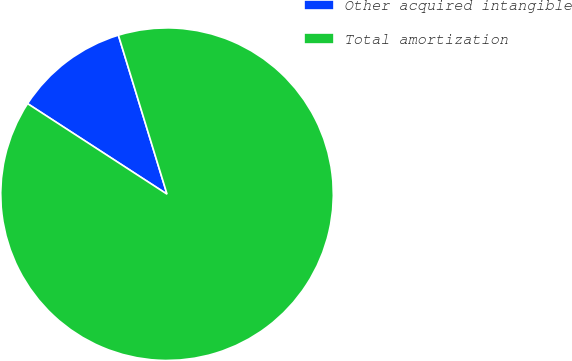Convert chart. <chart><loc_0><loc_0><loc_500><loc_500><pie_chart><fcel>Other acquired intangible<fcel>Total amortization<nl><fcel>11.11%<fcel>88.89%<nl></chart> 